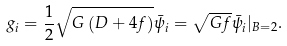Convert formula to latex. <formula><loc_0><loc_0><loc_500><loc_500>g _ { i } = \frac { 1 } { 2 } \sqrt { G \left ( D + 4 f \right ) } \bar { \psi } _ { i } = \sqrt { G f } \bar { \psi } _ { i } | _ { B = 2 } .</formula> 